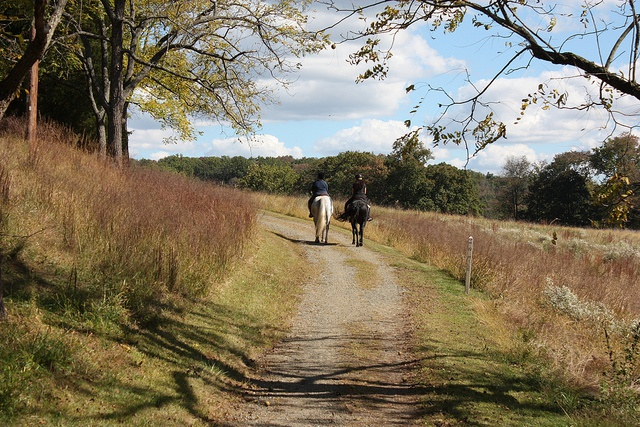Describe the objects in this image and their specific colors. I can see horse in black, ivory, and gray tones, horse in black and gray tones, people in black and gray tones, and people in black, gray, and darkblue tones in this image. 